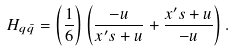<formula> <loc_0><loc_0><loc_500><loc_500>H _ { q \bar { q } } = \left ( \frac { 1 } { 6 } \right ) \left ( \frac { - u } { x ^ { \prime } s + u } + \frac { x ^ { \prime } s + u } { - u } \right ) .</formula> 